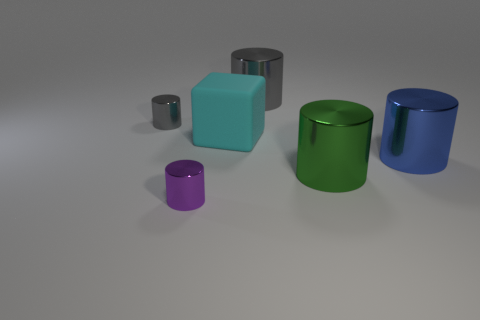Is the shape of the large matte thing the same as the blue thing?
Your answer should be very brief. No. There is a big object that is both in front of the big gray object and behind the big blue cylinder; what is it made of?
Your answer should be compact. Rubber. What is the size of the purple metal object?
Your response must be concise. Small. The other tiny object that is the same shape as the small purple shiny object is what color?
Your response must be concise. Gray. Do the gray shiny object that is right of the purple metal cylinder and the cyan thing that is on the right side of the small purple cylinder have the same size?
Make the answer very short. Yes. Are there the same number of shiny cylinders to the right of the purple shiny thing and objects in front of the cyan block?
Provide a short and direct response. Yes. Is the size of the cyan rubber object the same as the blue thing that is behind the green object?
Offer a terse response. Yes. Are there any small things on the left side of the gray thing that is to the right of the purple thing?
Make the answer very short. Yes. Are there any other big metallic objects of the same shape as the blue thing?
Your response must be concise. Yes. How many small purple cylinders are behind the gray metal thing in front of the large cylinder that is behind the tiny gray metal cylinder?
Your answer should be very brief. 0. 